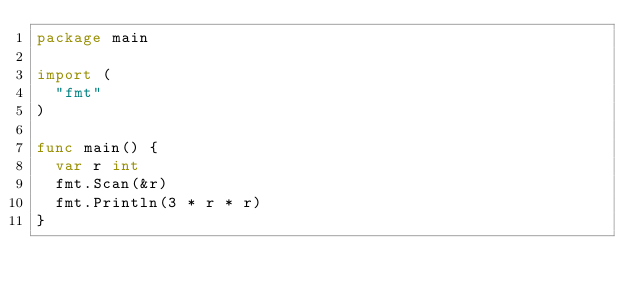<code> <loc_0><loc_0><loc_500><loc_500><_Go_>package main

import (
	"fmt"
)

func main() {
	var r int
	fmt.Scan(&r)
	fmt.Println(3 * r * r)
}
</code> 